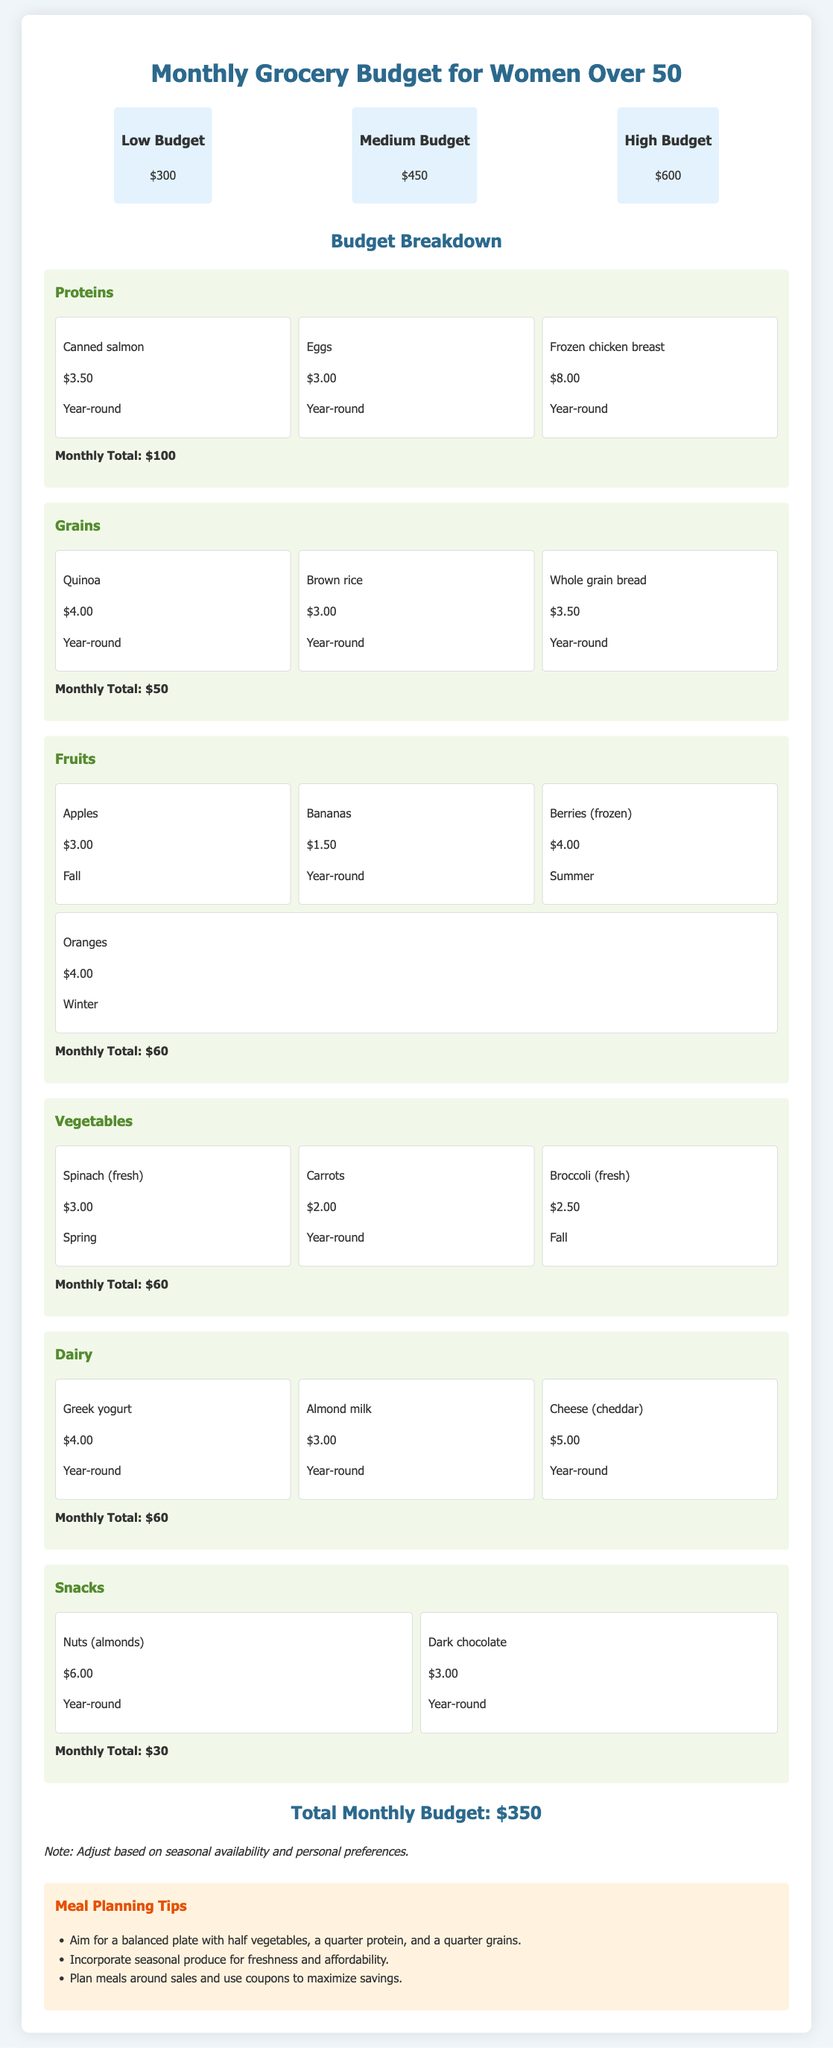What is the low budget for groceries? The low budget is mentioned at the beginning of the document, which is $300.
Answer: $300 What is the total monthly budget? The total monthly budget is calculated by summing the category totals listed in the document, resulting in $350.
Answer: $350 Which fruit is available in winter? The document lists seasonal fruits and their availability, where oranges are available in winter.
Answer: Oranges How much do eggs cost? The cost of eggs is provided under the proteins category in the budget, which is $3.00.
Answer: $3.00 What is the total amount budgeted for snacks? The snacks category total is stated as $30 in the breakdown of the budget.
Answer: $30 What is the recommended plate balance for meal planning? The meal planning tips suggest a balanced plate with half vegetables, a quarter protein, and a quarter grains.
Answer: Half vegetables, a quarter protein, a quarter grains Which vegetable is fresh and available in spring? The item list for vegetables indicates that spinach is fresh and available in spring.
Answer: Spinach What is the monthly total for fruits? The breakdown under the fruits category specifies the monthly total as $60.
Answer: $60 What is a suggested way to save on grocery expenses? The meal planning tips recommend planning meals around sales and using coupons to maximize savings.
Answer: Plan meals around sales and use coupons 